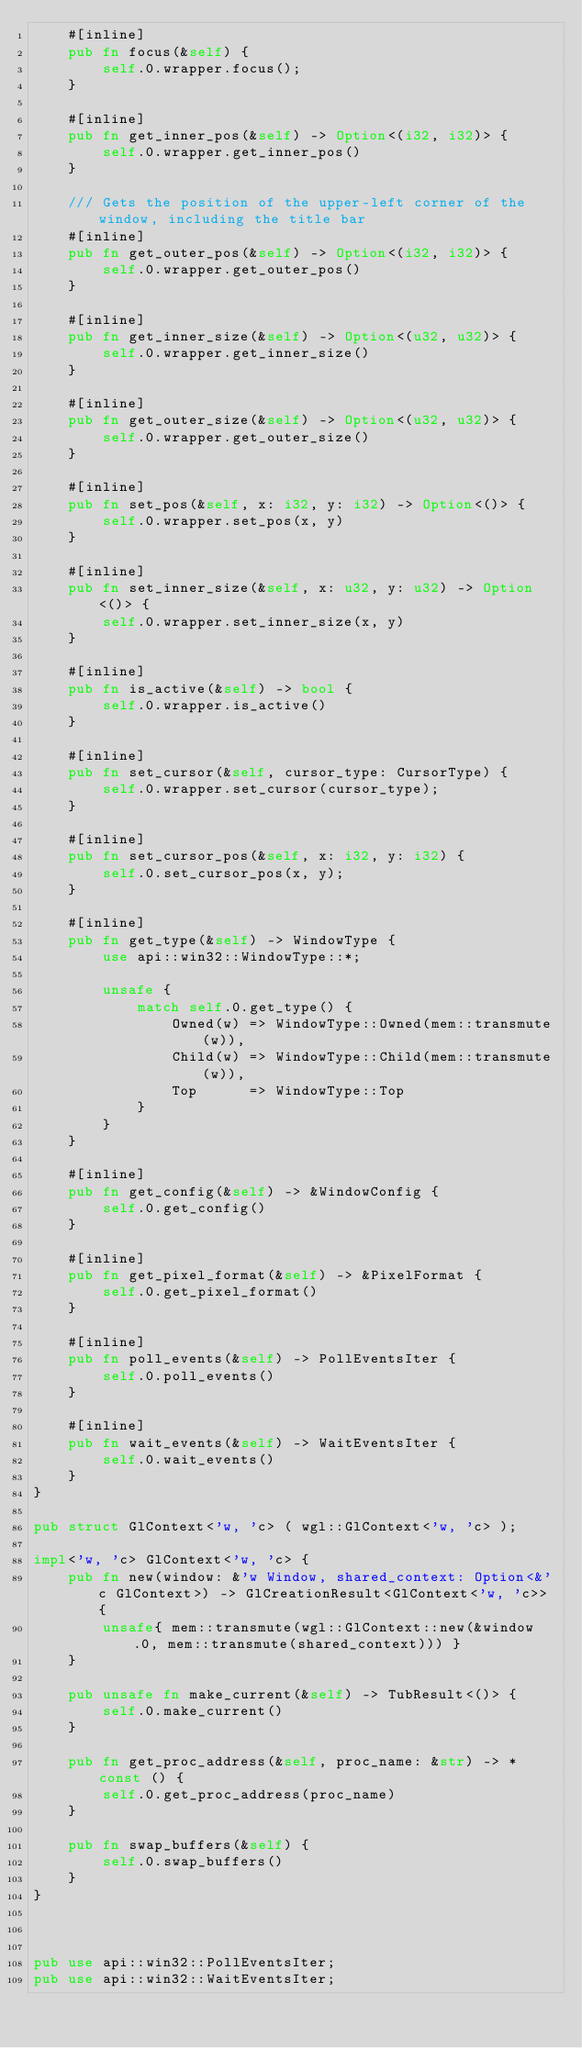<code> <loc_0><loc_0><loc_500><loc_500><_Rust_>    #[inline]
    pub fn focus(&self) {
        self.0.wrapper.focus();
    }

    #[inline]
    pub fn get_inner_pos(&self) -> Option<(i32, i32)> {
        self.0.wrapper.get_inner_pos()
    }

    /// Gets the position of the upper-left corner of the window, including the title bar
    #[inline]
    pub fn get_outer_pos(&self) -> Option<(i32, i32)> {
        self.0.wrapper.get_outer_pos()
    }

    #[inline]
    pub fn get_inner_size(&self) -> Option<(u32, u32)> {
        self.0.wrapper.get_inner_size()
    }

    #[inline]
    pub fn get_outer_size(&self) -> Option<(u32, u32)> {
        self.0.wrapper.get_outer_size()
    }

    #[inline]
    pub fn set_pos(&self, x: i32, y: i32) -> Option<()> {
        self.0.wrapper.set_pos(x, y)
    }

    #[inline]
    pub fn set_inner_size(&self, x: u32, y: u32) -> Option<()> {
        self.0.wrapper.set_inner_size(x, y)
    }

    #[inline]
    pub fn is_active(&self) -> bool {
        self.0.wrapper.is_active()
    }

    #[inline]
    pub fn set_cursor(&self, cursor_type: CursorType) {
        self.0.wrapper.set_cursor(cursor_type);
    }

    #[inline]
    pub fn set_cursor_pos(&self, x: i32, y: i32) {
        self.0.set_cursor_pos(x, y);
    }

    #[inline]
    pub fn get_type(&self) -> WindowType {
        use api::win32::WindowType::*;

        unsafe {
            match self.0.get_type() {
                Owned(w) => WindowType::Owned(mem::transmute(w)),
                Child(w) => WindowType::Child(mem::transmute(w)),
                Top      => WindowType::Top
            }
        }
    }

    #[inline]
    pub fn get_config(&self) -> &WindowConfig {
        self.0.get_config()
    }

    #[inline]
    pub fn get_pixel_format(&self) -> &PixelFormat {
        self.0.get_pixel_format()
    }

    #[inline]
    pub fn poll_events(&self) -> PollEventsIter {
        self.0.poll_events()
    }

    #[inline]
    pub fn wait_events(&self) -> WaitEventsIter {
        self.0.wait_events()
    }
}

pub struct GlContext<'w, 'c> ( wgl::GlContext<'w, 'c> );

impl<'w, 'c> GlContext<'w, 'c> {
    pub fn new(window: &'w Window, shared_context: Option<&'c GlContext>) -> GlCreationResult<GlContext<'w, 'c>> {
        unsafe{ mem::transmute(wgl::GlContext::new(&window.0, mem::transmute(shared_context))) }
    }

    pub unsafe fn make_current(&self) -> TubResult<()> {
        self.0.make_current()
    }

    pub fn get_proc_address(&self, proc_name: &str) -> *const () {
        self.0.get_proc_address(proc_name)
    }

    pub fn swap_buffers(&self) {
        self.0.swap_buffers()
    }
}



pub use api::win32::PollEventsIter;
pub use api::win32::WaitEventsIter;</code> 